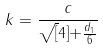<formula> <loc_0><loc_0><loc_500><loc_500>k = \frac { c } { \sqrt { [ } 4 ] { + \frac { d _ { 1 } } { 6 } } }</formula> 